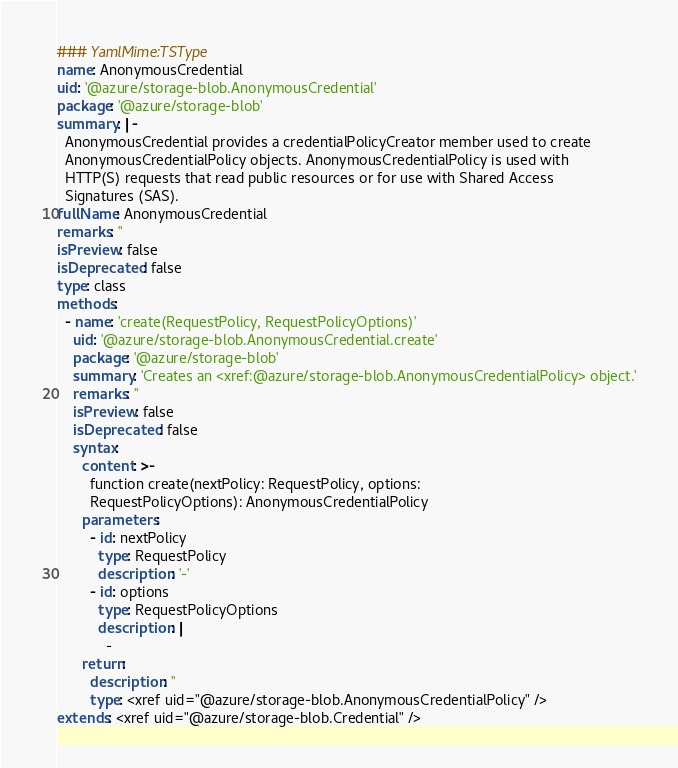<code> <loc_0><loc_0><loc_500><loc_500><_YAML_>### YamlMime:TSType
name: AnonymousCredential
uid: '@azure/storage-blob.AnonymousCredential'
package: '@azure/storage-blob'
summary: |-
  AnonymousCredential provides a credentialPolicyCreator member used to create
  AnonymousCredentialPolicy objects. AnonymousCredentialPolicy is used with
  HTTP(S) requests that read public resources or for use with Shared Access
  Signatures (SAS).
fullName: AnonymousCredential
remarks: ''
isPreview: false
isDeprecated: false
type: class
methods:
  - name: 'create(RequestPolicy, RequestPolicyOptions)'
    uid: '@azure/storage-blob.AnonymousCredential.create'
    package: '@azure/storage-blob'
    summary: 'Creates an <xref:@azure/storage-blob.AnonymousCredentialPolicy> object.'
    remarks: ''
    isPreview: false
    isDeprecated: false
    syntax:
      content: >-
        function create(nextPolicy: RequestPolicy, options:
        RequestPolicyOptions): AnonymousCredentialPolicy
      parameters:
        - id: nextPolicy
          type: RequestPolicy
          description: '-'
        - id: options
          type: RequestPolicyOptions
          description: |
            -
      return:
        description: ''
        type: <xref uid="@azure/storage-blob.AnonymousCredentialPolicy" />
extends: <xref uid="@azure/storage-blob.Credential" />
</code> 